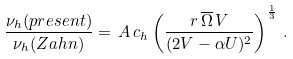<formula> <loc_0><loc_0><loc_500><loc_500>\frac { \nu _ { h } ( p r e s e n t ) } { \nu _ { h } ( Z a h n ) } = \, A \, c _ { h } \left ( { \frac { r \, \overline { \Omega } \, V } { ( 2 V - \alpha U ) ^ { 2 } } } \right ) ^ { \frac { 1 } { 3 } } \, .</formula> 